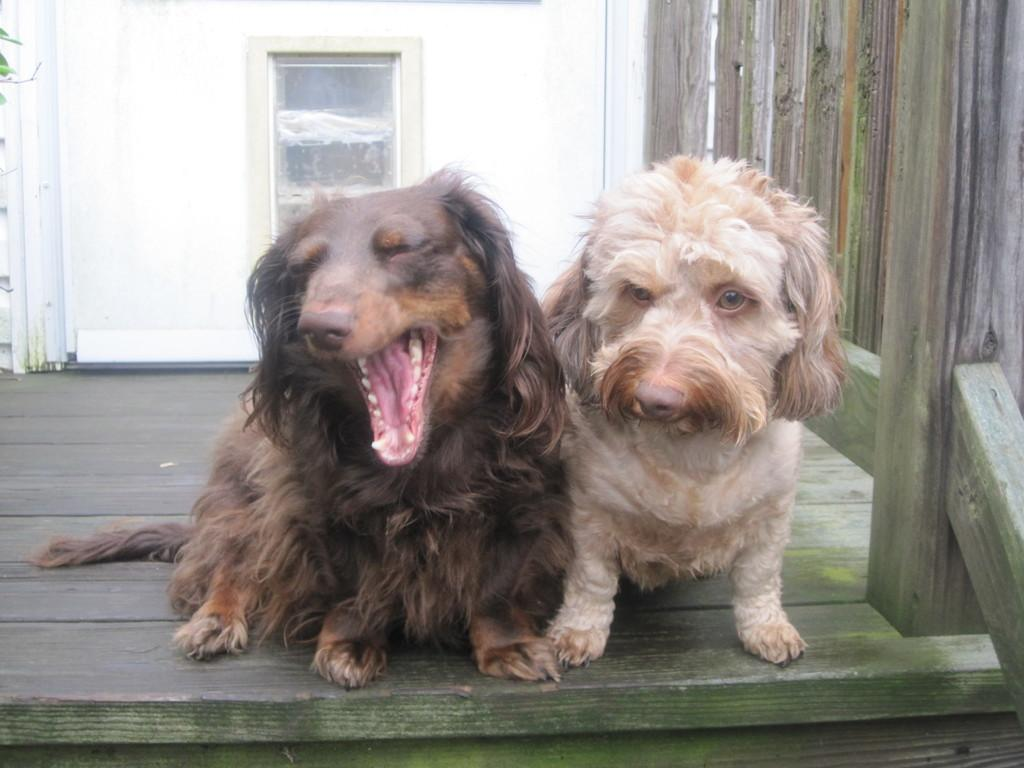What animals are present in the image? There are dogs in the image. What surface are the dogs sitting on? The dogs are sitting on wood. What type of door can be seen in the image? There is a glass door visible in the image. How is the glass door attached to the surrounding structure? The glass door is connected to a wall. What type of alley can be seen behind the dogs in the image? There is no alley visible in the image; it only shows dogs sitting on wood and a glass door connected to a wall. 